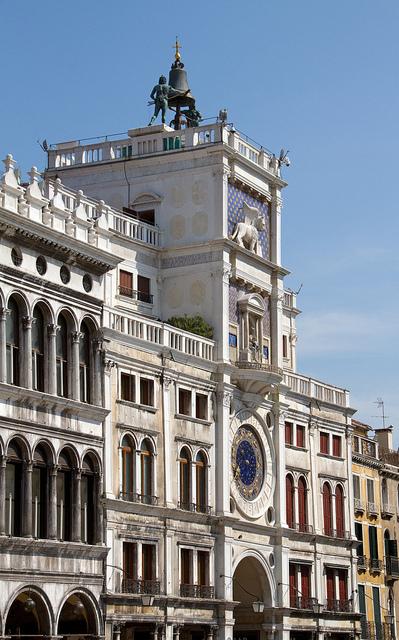What color is the building?
Keep it brief. White. Is this a big building?
Write a very short answer. Yes. Are there archways?
Answer briefly. Yes. 